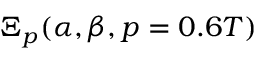<formula> <loc_0><loc_0><loc_500><loc_500>\Xi _ { p } ( \alpha , \beta , p = 0 . 6 T )</formula> 